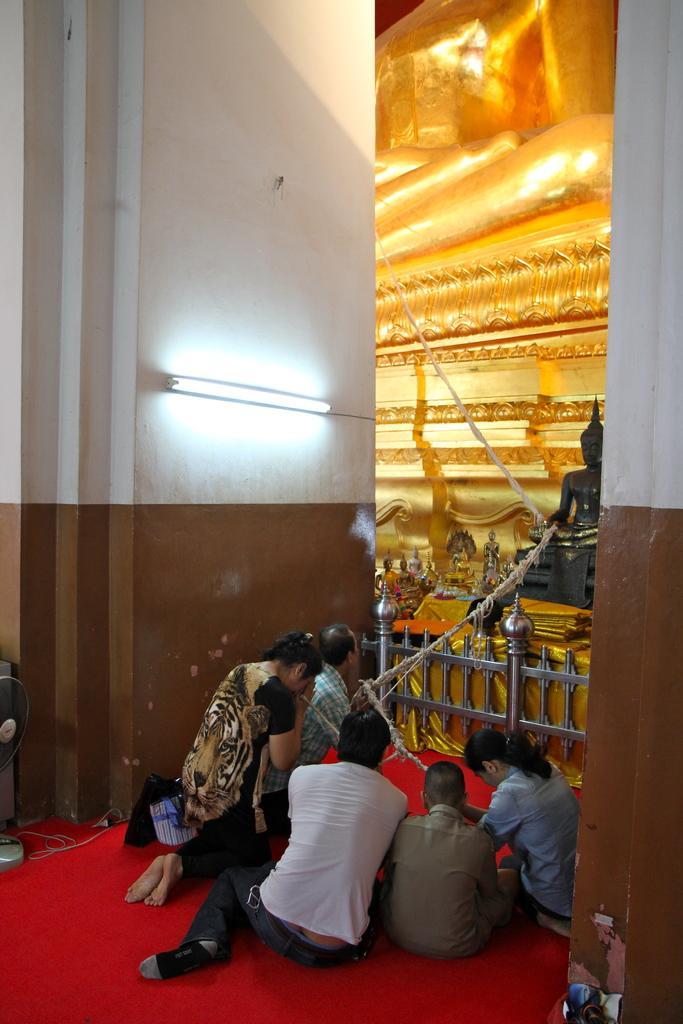Describe this image in one or two sentences. In this image there are persons sitting, there is a fence, there are lights and there is a sculpture and there are objects in the background. In the front on the left side there is a fan which is visible. On the floor there is a mat which is red in colour. 